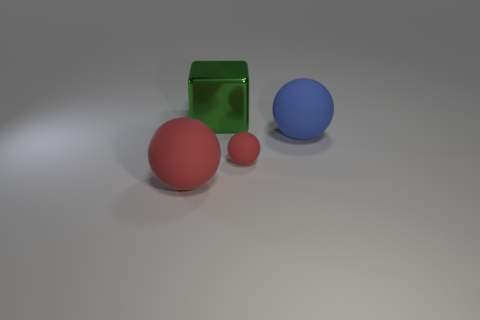Is there any other thing that has the same material as the big cube?
Offer a terse response. No. Does the small red rubber thing have the same shape as the large red thing?
Provide a succinct answer. Yes. What is the size of the green thing behind the blue rubber sphere that is behind the big rubber ball that is on the left side of the blue matte ball?
Provide a succinct answer. Large. What is the small red sphere made of?
Keep it short and to the point. Rubber. There is a blue thing; is its shape the same as the object behind the blue ball?
Offer a very short reply. No. There is a big cube that is to the right of the big rubber thing that is in front of the big matte object on the right side of the large red object; what is it made of?
Keep it short and to the point. Metal. How many tiny red rubber spheres are there?
Provide a succinct answer. 1. What number of cyan things are either rubber balls or big rubber things?
Make the answer very short. 0. What number of other objects are the same shape as the big green metal thing?
Your answer should be very brief. 0. There is a big matte object that is to the left of the large blue ball; is its color the same as the small rubber ball right of the big red matte sphere?
Provide a succinct answer. Yes. 